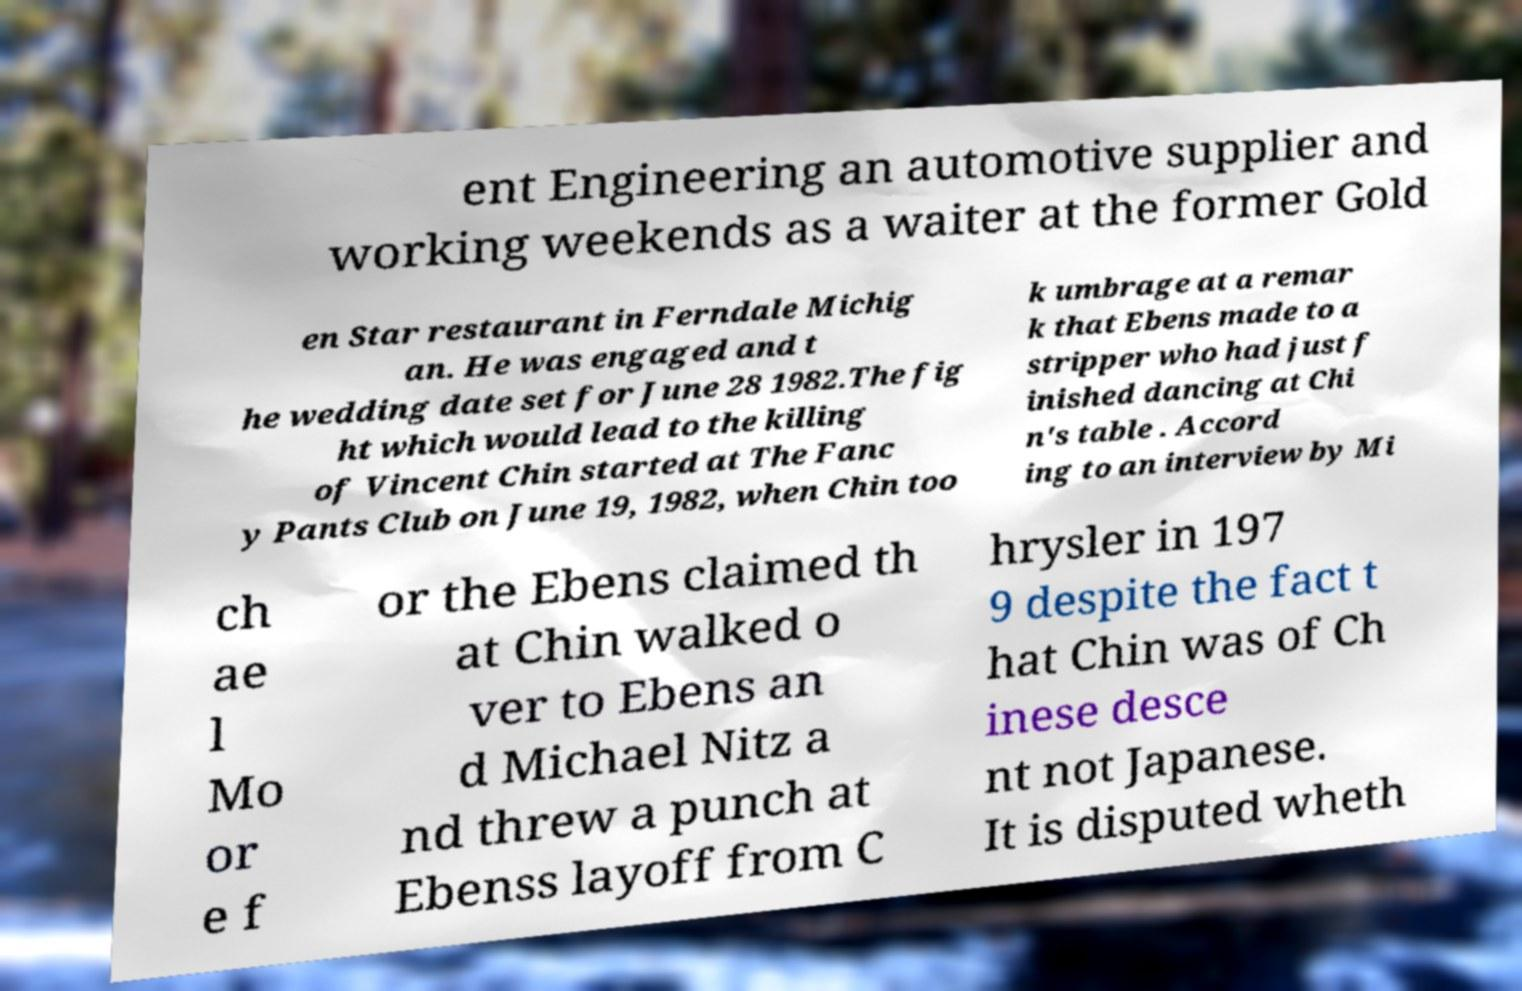There's text embedded in this image that I need extracted. Can you transcribe it verbatim? ent Engineering an automotive supplier and working weekends as a waiter at the former Gold en Star restaurant in Ferndale Michig an. He was engaged and t he wedding date set for June 28 1982.The fig ht which would lead to the killing of Vincent Chin started at The Fanc y Pants Club on June 19, 1982, when Chin too k umbrage at a remar k that Ebens made to a stripper who had just f inished dancing at Chi n's table . Accord ing to an interview by Mi ch ae l Mo or e f or the Ebens claimed th at Chin walked o ver to Ebens an d Michael Nitz a nd threw a punch at Ebenss layoff from C hrysler in 197 9 despite the fact t hat Chin was of Ch inese desce nt not Japanese. It is disputed wheth 